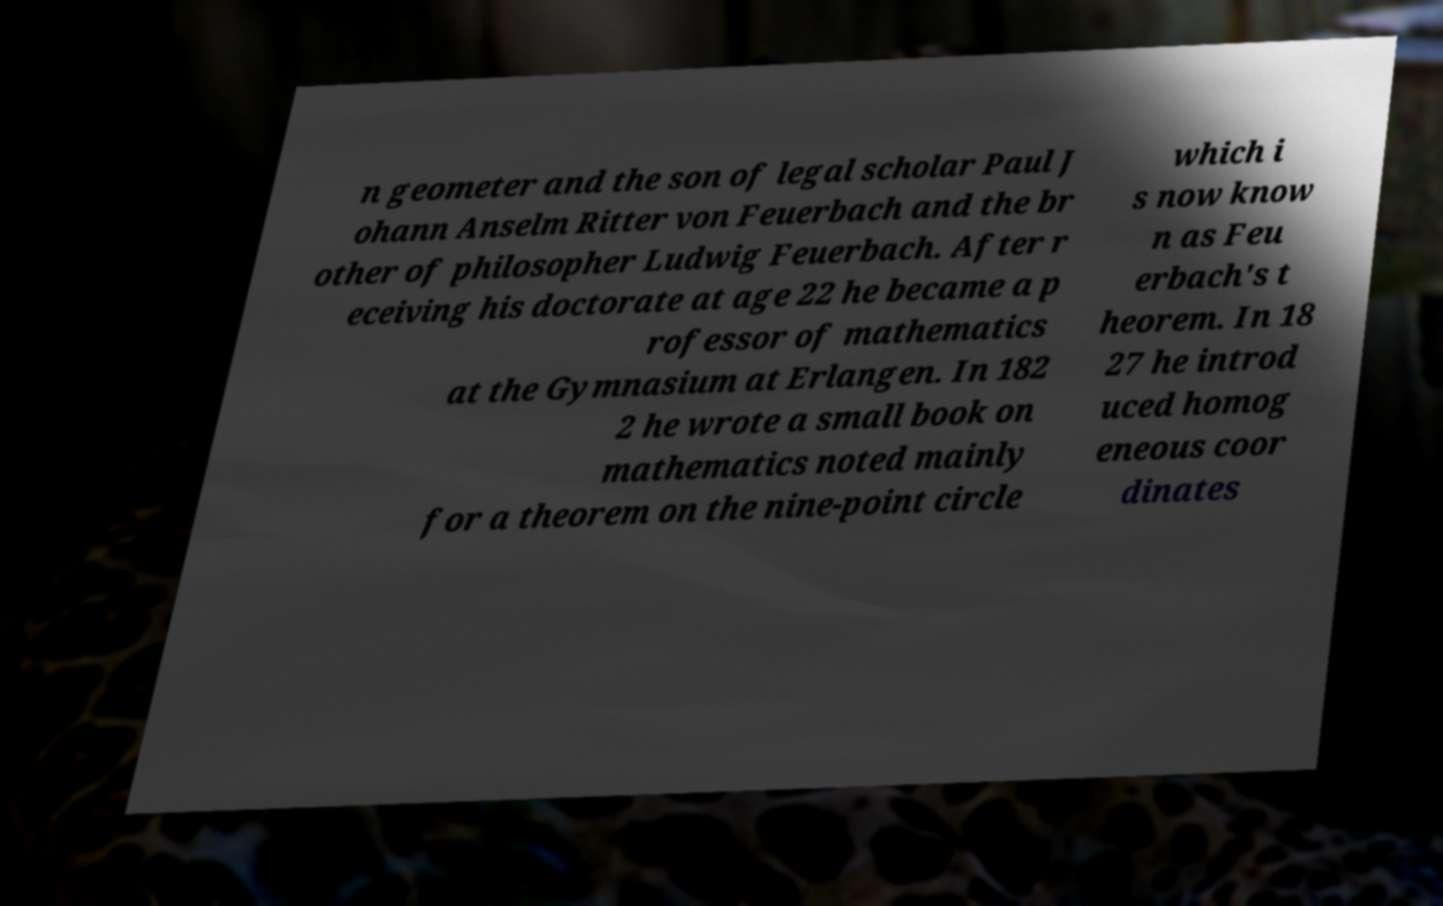I need the written content from this picture converted into text. Can you do that? n geometer and the son of legal scholar Paul J ohann Anselm Ritter von Feuerbach and the br other of philosopher Ludwig Feuerbach. After r eceiving his doctorate at age 22 he became a p rofessor of mathematics at the Gymnasium at Erlangen. In 182 2 he wrote a small book on mathematics noted mainly for a theorem on the nine-point circle which i s now know n as Feu erbach's t heorem. In 18 27 he introd uced homog eneous coor dinates 